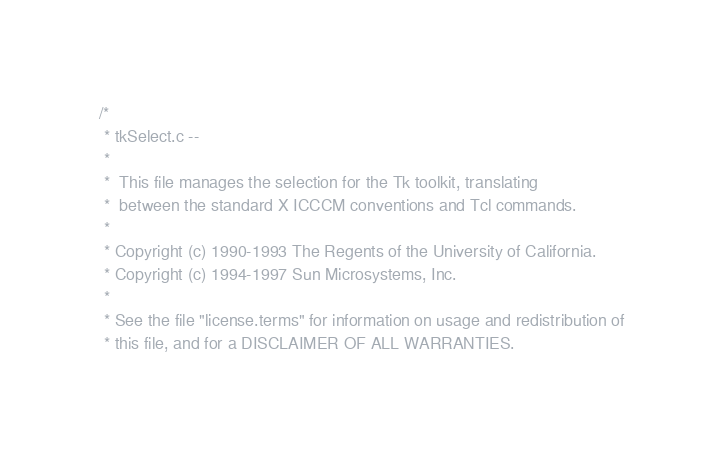<code> <loc_0><loc_0><loc_500><loc_500><_C_>/*
 * tkSelect.c --
 *
 *	This file manages the selection for the Tk toolkit, translating
 *	between the standard X ICCCM conventions and Tcl commands.
 *
 * Copyright (c) 1990-1993 The Regents of the University of California.
 * Copyright (c) 1994-1997 Sun Microsystems, Inc.
 *
 * See the file "license.terms" for information on usage and redistribution of
 * this file, and for a DISCLAIMER OF ALL WARRANTIES.</code> 